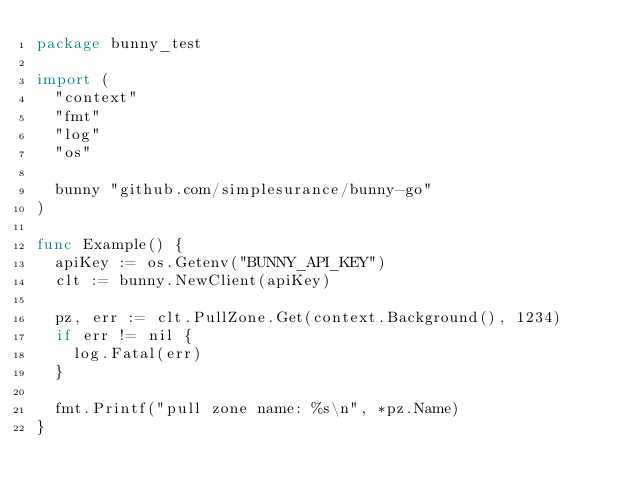<code> <loc_0><loc_0><loc_500><loc_500><_Go_>package bunny_test

import (
	"context"
	"fmt"
	"log"
	"os"

	bunny "github.com/simplesurance/bunny-go"
)

func Example() {
	apiKey := os.Getenv("BUNNY_API_KEY")
	clt := bunny.NewClient(apiKey)

	pz, err := clt.PullZone.Get(context.Background(), 1234)
	if err != nil {
		log.Fatal(err)
	}

	fmt.Printf("pull zone name: %s\n", *pz.Name)
}
</code> 